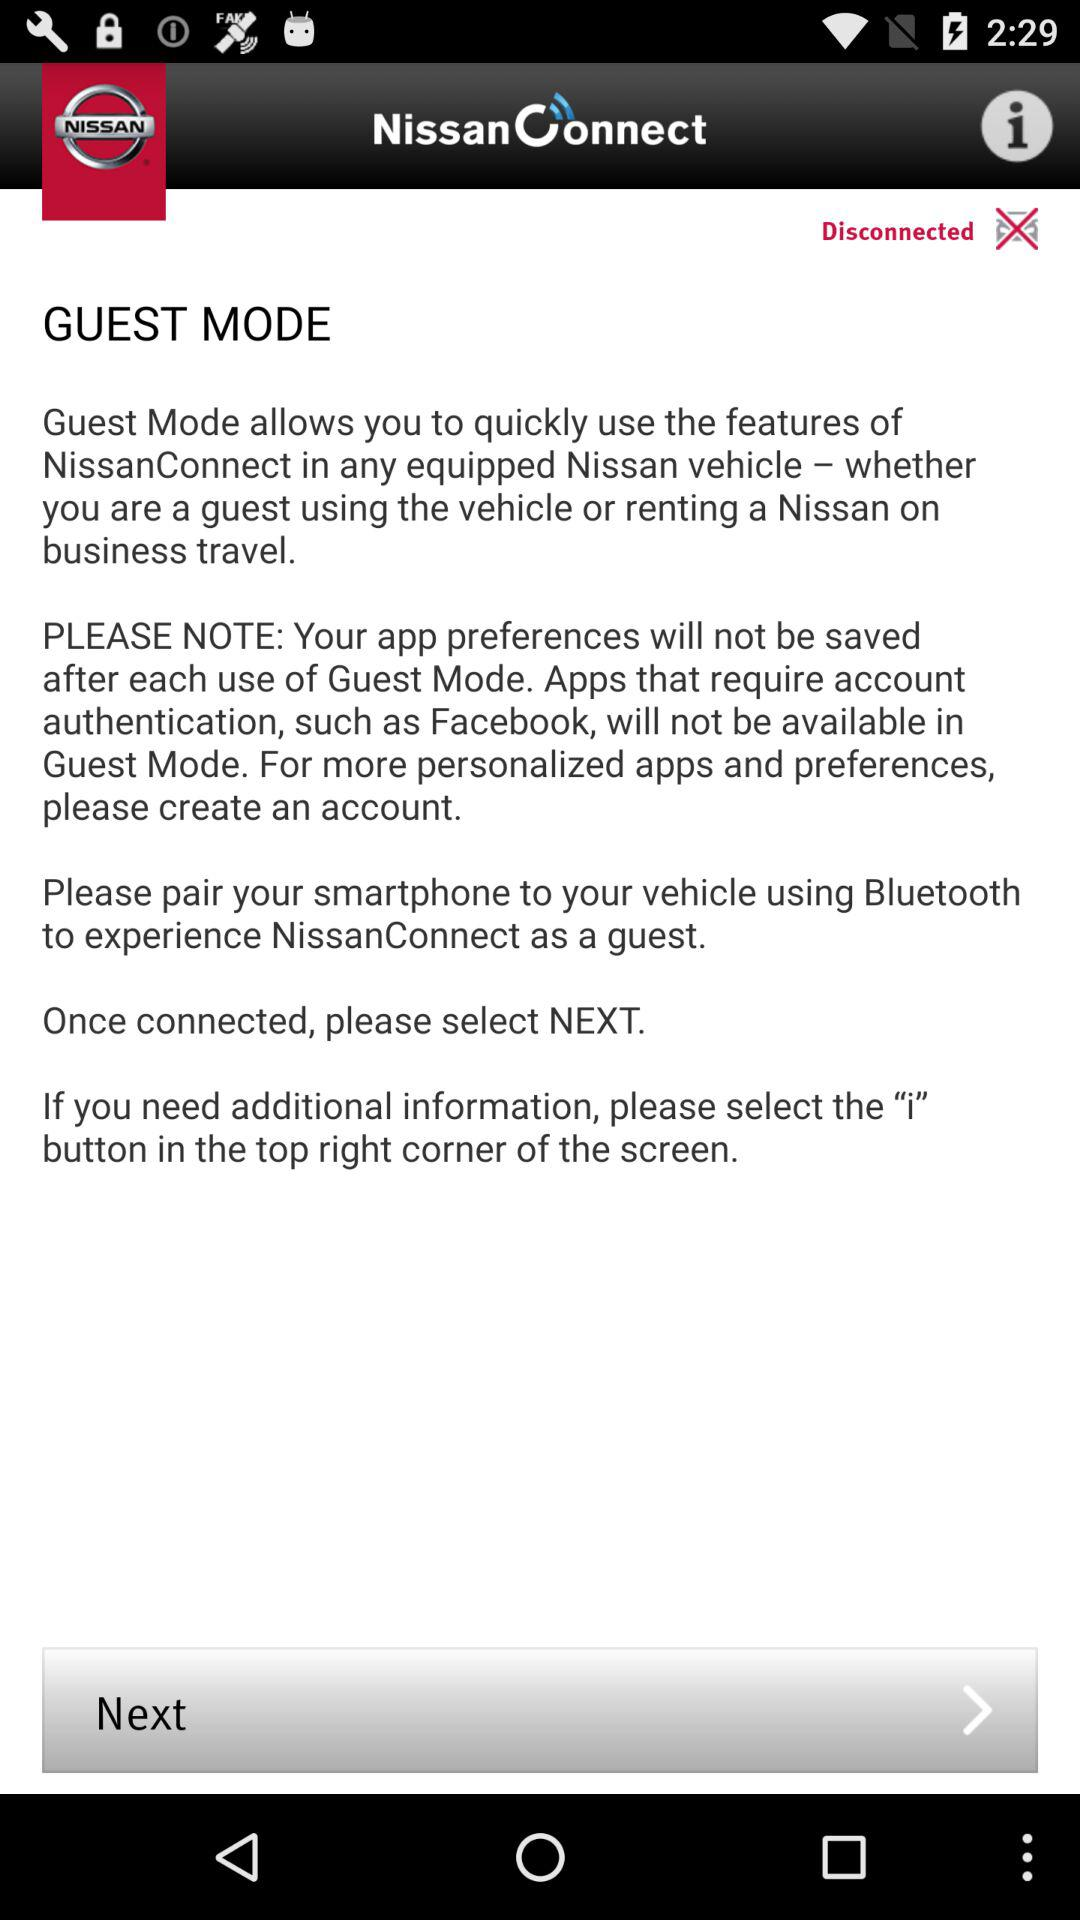What version of the application is being used?
When the provided information is insufficient, respond with <no answer>. <no answer> 